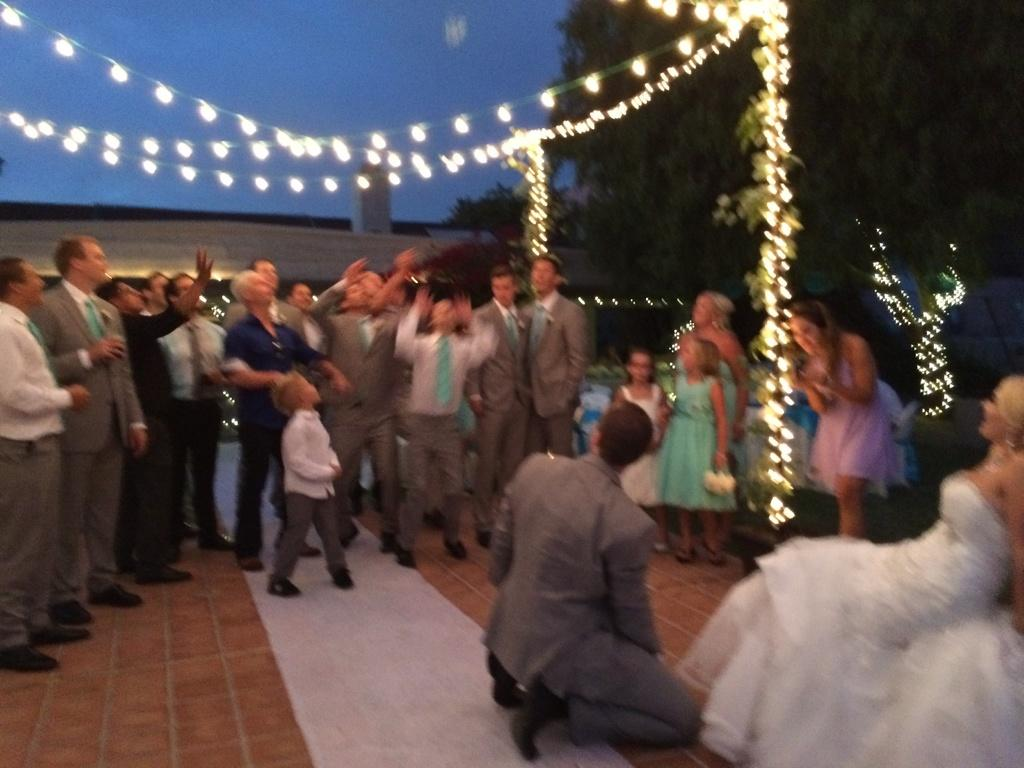Who or what is present in the image? There are people in the image. What decorative elements can be seen in the image? Light strings are visible in the image. What type of natural elements are in the image? There are trees in the image. What is on the ground in the image? A floor mat is present in the image. What can be seen in the distance in the image? The sky is visible in the background of the image. Are there any dinosaurs visible in the image? No, there are no dinosaurs present in the image. 